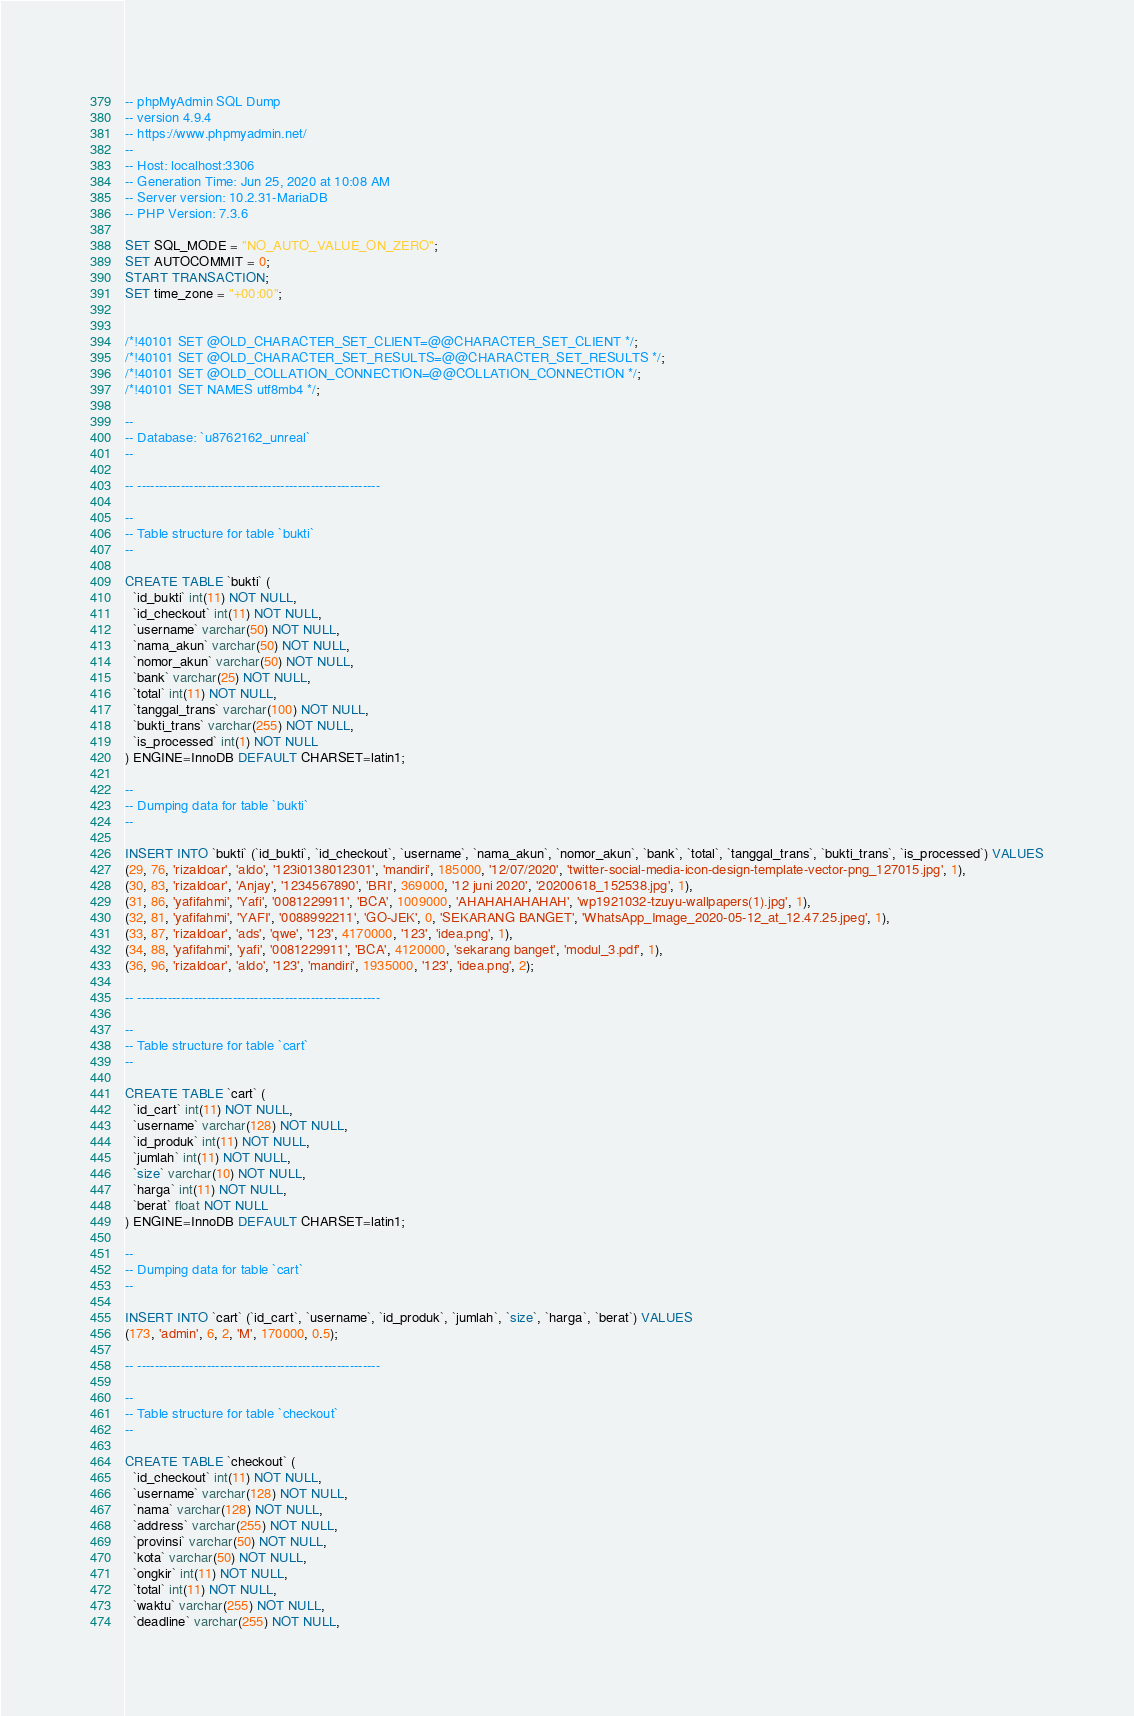Convert code to text. <code><loc_0><loc_0><loc_500><loc_500><_SQL_>-- phpMyAdmin SQL Dump
-- version 4.9.4
-- https://www.phpmyadmin.net/
--
-- Host: localhost:3306
-- Generation Time: Jun 25, 2020 at 10:08 AM
-- Server version: 10.2.31-MariaDB
-- PHP Version: 7.3.6

SET SQL_MODE = "NO_AUTO_VALUE_ON_ZERO";
SET AUTOCOMMIT = 0;
START TRANSACTION;
SET time_zone = "+00:00";


/*!40101 SET @OLD_CHARACTER_SET_CLIENT=@@CHARACTER_SET_CLIENT */;
/*!40101 SET @OLD_CHARACTER_SET_RESULTS=@@CHARACTER_SET_RESULTS */;
/*!40101 SET @OLD_COLLATION_CONNECTION=@@COLLATION_CONNECTION */;
/*!40101 SET NAMES utf8mb4 */;

--
-- Database: `u8762162_unreal`
--

-- --------------------------------------------------------

--
-- Table structure for table `bukti`
--

CREATE TABLE `bukti` (
  `id_bukti` int(11) NOT NULL,
  `id_checkout` int(11) NOT NULL,
  `username` varchar(50) NOT NULL,
  `nama_akun` varchar(50) NOT NULL,
  `nomor_akun` varchar(50) NOT NULL,
  `bank` varchar(25) NOT NULL,
  `total` int(11) NOT NULL,
  `tanggal_trans` varchar(100) NOT NULL,
  `bukti_trans` varchar(255) NOT NULL,
  `is_processed` int(1) NOT NULL
) ENGINE=InnoDB DEFAULT CHARSET=latin1;

--
-- Dumping data for table `bukti`
--

INSERT INTO `bukti` (`id_bukti`, `id_checkout`, `username`, `nama_akun`, `nomor_akun`, `bank`, `total`, `tanggal_trans`, `bukti_trans`, `is_processed`) VALUES
(29, 76, 'rizaldoar', 'aldo', '123i0138012301', 'mandiri', 185000, '12/07/2020', 'twitter-social-media-icon-design-template-vector-png_127015.jpg', 1),
(30, 83, 'rizaldoar', 'Anjay', '1234567890', 'BRI', 369000, '12 juni 2020', '20200618_152538.jpg', 1),
(31, 86, 'yafifahmi', 'Yafi', '0081229911', 'BCA', 1009000, 'AHAHAHAHAHAH', 'wp1921032-tzuyu-wallpapers(1).jpg', 1),
(32, 81, 'yafifahmi', 'YAFI', '0088992211', 'GO-JEK', 0, 'SEKARANG BANGET', 'WhatsApp_Image_2020-05-12_at_12.47.25.jpeg', 1),
(33, 87, 'rizaldoar', 'ads', 'qwe', '123', 4170000, '123', 'idea.png', 1),
(34, 88, 'yafifahmi', 'yafi', '0081229911', 'BCA', 4120000, 'sekarang banget', 'modul_3.pdf', 1),
(36, 96, 'rizaldoar', 'aldo', '123', 'mandiri', 1935000, '123', 'idea.png', 2);

-- --------------------------------------------------------

--
-- Table structure for table `cart`
--

CREATE TABLE `cart` (
  `id_cart` int(11) NOT NULL,
  `username` varchar(128) NOT NULL,
  `id_produk` int(11) NOT NULL,
  `jumlah` int(11) NOT NULL,
  `size` varchar(10) NOT NULL,
  `harga` int(11) NOT NULL,
  `berat` float NOT NULL
) ENGINE=InnoDB DEFAULT CHARSET=latin1;

--
-- Dumping data for table `cart`
--

INSERT INTO `cart` (`id_cart`, `username`, `id_produk`, `jumlah`, `size`, `harga`, `berat`) VALUES
(173, 'admin', 6, 2, 'M', 170000, 0.5);

-- --------------------------------------------------------

--
-- Table structure for table `checkout`
--

CREATE TABLE `checkout` (
  `id_checkout` int(11) NOT NULL,
  `username` varchar(128) NOT NULL,
  `nama` varchar(128) NOT NULL,
  `address` varchar(255) NOT NULL,
  `provinsi` varchar(50) NOT NULL,
  `kota` varchar(50) NOT NULL,
  `ongkir` int(11) NOT NULL,
  `total` int(11) NOT NULL,
  `waktu` varchar(255) NOT NULL,
  `deadline` varchar(255) NOT NULL,</code> 